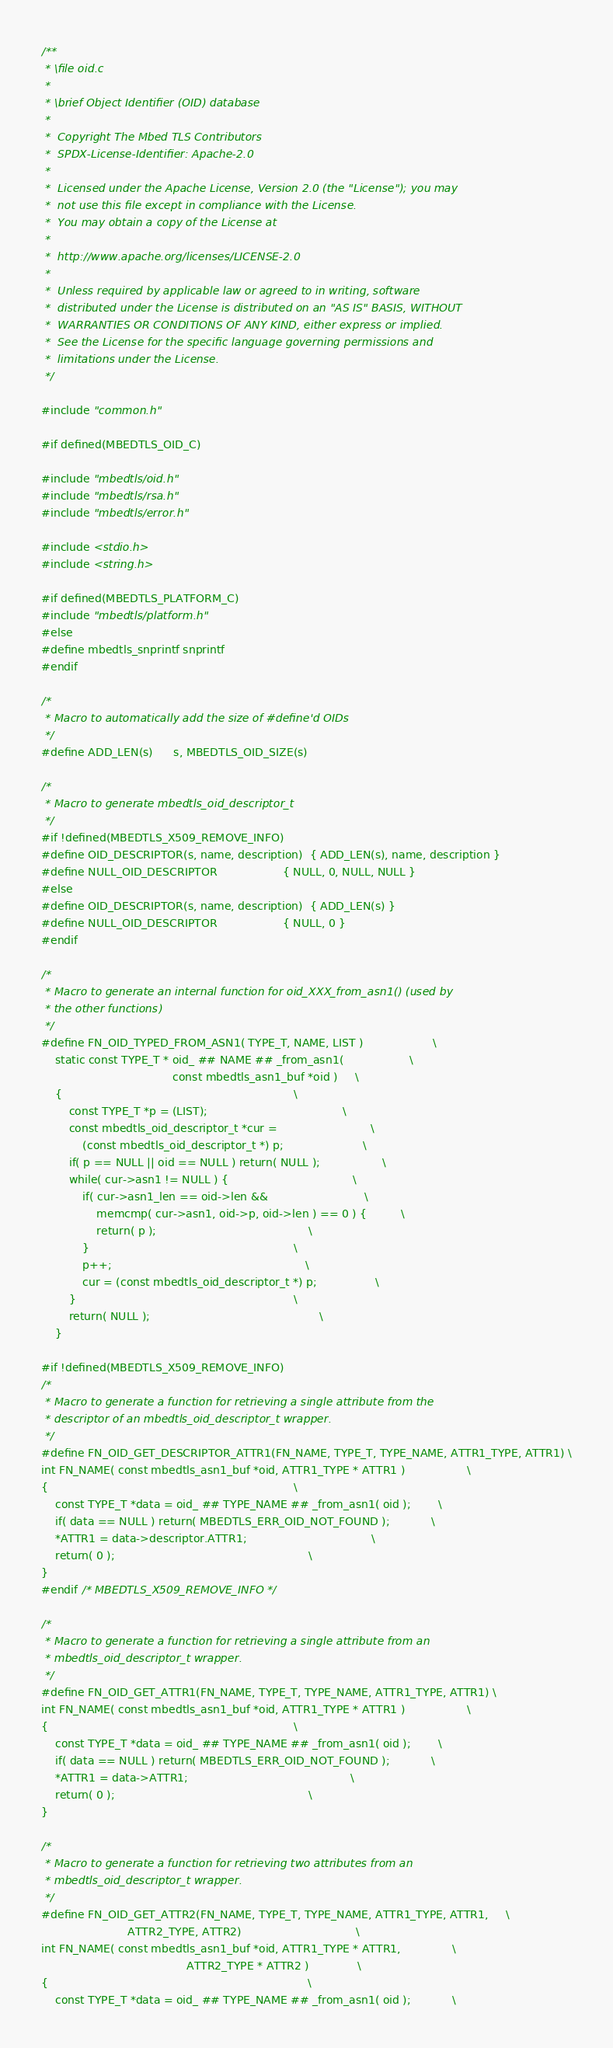Convert code to text. <code><loc_0><loc_0><loc_500><loc_500><_C_>/**
 * \file oid.c
 *
 * \brief Object Identifier (OID) database
 *
 *  Copyright The Mbed TLS Contributors
 *  SPDX-License-Identifier: Apache-2.0
 *
 *  Licensed under the Apache License, Version 2.0 (the "License"); you may
 *  not use this file except in compliance with the License.
 *  You may obtain a copy of the License at
 *
 *  http://www.apache.org/licenses/LICENSE-2.0
 *
 *  Unless required by applicable law or agreed to in writing, software
 *  distributed under the License is distributed on an "AS IS" BASIS, WITHOUT
 *  WARRANTIES OR CONDITIONS OF ANY KIND, either express or implied.
 *  See the License for the specific language governing permissions and
 *  limitations under the License.
 */

#include "common.h"

#if defined(MBEDTLS_OID_C)

#include "mbedtls/oid.h"
#include "mbedtls/rsa.h"
#include "mbedtls/error.h"

#include <stdio.h>
#include <string.h>

#if defined(MBEDTLS_PLATFORM_C)
#include "mbedtls/platform.h"
#else
#define mbedtls_snprintf snprintf
#endif

/*
 * Macro to automatically add the size of #define'd OIDs
 */
#define ADD_LEN(s)      s, MBEDTLS_OID_SIZE(s)

/*
 * Macro to generate mbedtls_oid_descriptor_t
 */
#if !defined(MBEDTLS_X509_REMOVE_INFO)
#define OID_DESCRIPTOR(s, name, description)  { ADD_LEN(s), name, description }
#define NULL_OID_DESCRIPTOR                   { NULL, 0, NULL, NULL }
#else
#define OID_DESCRIPTOR(s, name, description)  { ADD_LEN(s) }
#define NULL_OID_DESCRIPTOR                   { NULL, 0 }
#endif

/*
 * Macro to generate an internal function for oid_XXX_from_asn1() (used by
 * the other functions)
 */
#define FN_OID_TYPED_FROM_ASN1( TYPE_T, NAME, LIST )                    \
    static const TYPE_T * oid_ ## NAME ## _from_asn1(                   \
                                      const mbedtls_asn1_buf *oid )     \
    {                                                                   \
        const TYPE_T *p = (LIST);                                       \
        const mbedtls_oid_descriptor_t *cur =                           \
            (const mbedtls_oid_descriptor_t *) p;                       \
        if( p == NULL || oid == NULL ) return( NULL );                  \
        while( cur->asn1 != NULL ) {                                    \
            if( cur->asn1_len == oid->len &&                            \
                memcmp( cur->asn1, oid->p, oid->len ) == 0 ) {          \
                return( p );                                            \
            }                                                           \
            p++;                                                        \
            cur = (const mbedtls_oid_descriptor_t *) p;                 \
        }                                                               \
        return( NULL );                                                 \
    }

#if !defined(MBEDTLS_X509_REMOVE_INFO)
/*
 * Macro to generate a function for retrieving a single attribute from the
 * descriptor of an mbedtls_oid_descriptor_t wrapper.
 */
#define FN_OID_GET_DESCRIPTOR_ATTR1(FN_NAME, TYPE_T, TYPE_NAME, ATTR1_TYPE, ATTR1) \
int FN_NAME( const mbedtls_asn1_buf *oid, ATTR1_TYPE * ATTR1 )                  \
{                                                                       \
    const TYPE_T *data = oid_ ## TYPE_NAME ## _from_asn1( oid );        \
    if( data == NULL ) return( MBEDTLS_ERR_OID_NOT_FOUND );            \
    *ATTR1 = data->descriptor.ATTR1;                                    \
    return( 0 );                                                        \
}
#endif /* MBEDTLS_X509_REMOVE_INFO */

/*
 * Macro to generate a function for retrieving a single attribute from an
 * mbedtls_oid_descriptor_t wrapper.
 */
#define FN_OID_GET_ATTR1(FN_NAME, TYPE_T, TYPE_NAME, ATTR1_TYPE, ATTR1) \
int FN_NAME( const mbedtls_asn1_buf *oid, ATTR1_TYPE * ATTR1 )                  \
{                                                                       \
    const TYPE_T *data = oid_ ## TYPE_NAME ## _from_asn1( oid );        \
    if( data == NULL ) return( MBEDTLS_ERR_OID_NOT_FOUND );            \
    *ATTR1 = data->ATTR1;                                               \
    return( 0 );                                                        \
}

/*
 * Macro to generate a function for retrieving two attributes from an
 * mbedtls_oid_descriptor_t wrapper.
 */
#define FN_OID_GET_ATTR2(FN_NAME, TYPE_T, TYPE_NAME, ATTR1_TYPE, ATTR1,     \
                         ATTR2_TYPE, ATTR2)                                 \
int FN_NAME( const mbedtls_asn1_buf *oid, ATTR1_TYPE * ATTR1,               \
                                          ATTR2_TYPE * ATTR2 )              \
{                                                                           \
    const TYPE_T *data = oid_ ## TYPE_NAME ## _from_asn1( oid );            \</code> 